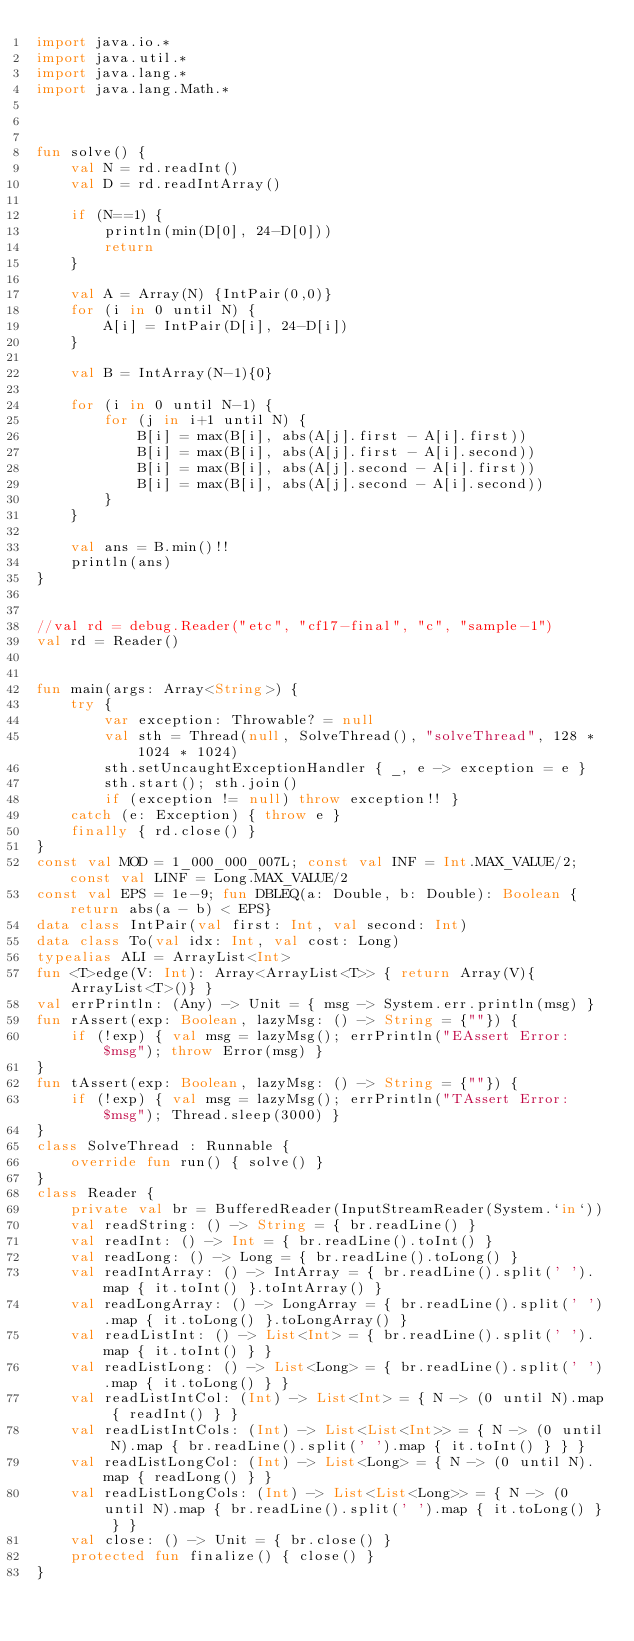<code> <loc_0><loc_0><loc_500><loc_500><_Kotlin_>import java.io.*
import java.util.*
import java.lang.*
import java.lang.Math.*



fun solve() {
    val N = rd.readInt()
    val D = rd.readIntArray()

    if (N==1) {
        println(min(D[0], 24-D[0]))
        return
    }

    val A = Array(N) {IntPair(0,0)}
    for (i in 0 until N) {
        A[i] = IntPair(D[i], 24-D[i])
    }

    val B = IntArray(N-1){0}

    for (i in 0 until N-1) {
        for (j in i+1 until N) {
            B[i] = max(B[i], abs(A[j].first - A[i].first))
            B[i] = max(B[i], abs(A[j].first - A[i].second))
            B[i] = max(B[i], abs(A[j].second - A[i].first))
            B[i] = max(B[i], abs(A[j].second - A[i].second))
        }
    }

    val ans = B.min()!!
    println(ans)
}


//val rd = debug.Reader("etc", "cf17-final", "c", "sample-1")
val rd = Reader()


fun main(args: Array<String>) {
    try {
        var exception: Throwable? = null
        val sth = Thread(null, SolveThread(), "solveThread", 128 * 1024 * 1024)
        sth.setUncaughtExceptionHandler { _, e -> exception = e }
        sth.start(); sth.join()
        if (exception != null) throw exception!! }
    catch (e: Exception) { throw e }
    finally { rd.close() }
}
const val MOD = 1_000_000_007L; const val INF = Int.MAX_VALUE/2; const val LINF = Long.MAX_VALUE/2
const val EPS = 1e-9; fun DBLEQ(a: Double, b: Double): Boolean {return abs(a - b) < EPS}
data class IntPair(val first: Int, val second: Int)
data class To(val idx: Int, val cost: Long)
typealias ALI = ArrayList<Int>
fun <T>edge(V: Int): Array<ArrayList<T>> { return Array(V){ArrayList<T>()} }
val errPrintln: (Any) -> Unit = { msg -> System.err.println(msg) }
fun rAssert(exp: Boolean, lazyMsg: () -> String = {""}) {
    if (!exp) { val msg = lazyMsg(); errPrintln("EAssert Error: $msg"); throw Error(msg) }
}
fun tAssert(exp: Boolean, lazyMsg: () -> String = {""}) {
    if (!exp) { val msg = lazyMsg(); errPrintln("TAssert Error: $msg"); Thread.sleep(3000) }
}
class SolveThread : Runnable {
    override fun run() { solve() }
}
class Reader {
    private val br = BufferedReader(InputStreamReader(System.`in`))
    val readString: () -> String = { br.readLine() }
    val readInt: () -> Int = { br.readLine().toInt() }
    val readLong: () -> Long = { br.readLine().toLong() }
    val readIntArray: () -> IntArray = { br.readLine().split(' ').map { it.toInt() }.toIntArray() }
    val readLongArray: () -> LongArray = { br.readLine().split(' ').map { it.toLong() }.toLongArray() }
    val readListInt: () -> List<Int> = { br.readLine().split(' ').map { it.toInt() } }
    val readListLong: () -> List<Long> = { br.readLine().split(' ').map { it.toLong() } }
    val readListIntCol: (Int) -> List<Int> = { N -> (0 until N).map { readInt() } }
    val readListIntCols: (Int) -> List<List<Int>> = { N -> (0 until N).map { br.readLine().split(' ').map { it.toInt() } } }
    val readListLongCol: (Int) -> List<Long> = { N -> (0 until N).map { readLong() } }
    val readListLongCols: (Int) -> List<List<Long>> = { N -> (0 until N).map { br.readLine().split(' ').map { it.toLong() } } }
    val close: () -> Unit = { br.close() }
    protected fun finalize() { close() }
}
</code> 